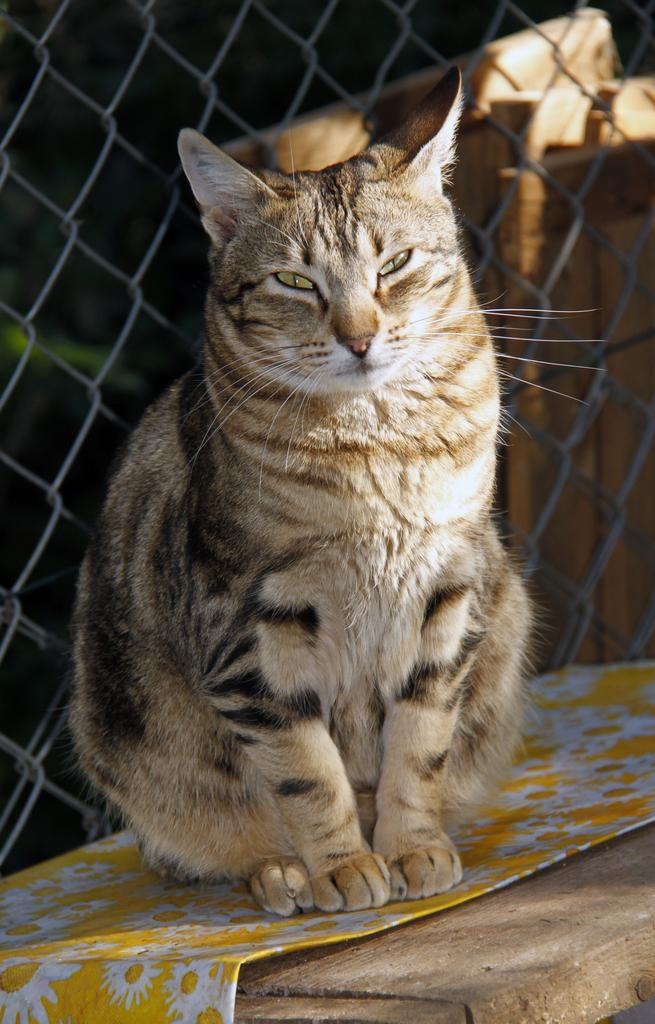What animal is on the wooden table in the image? There is a cat on a wooden table in the image. What is covering the table in the image? The table has a cover on it. What can be seen behind the cat in the image? There is a mesh fence behind the cat. What is located behind the mesh fence in the image? There are wooden planks behind the fence. What type of shock can be seen in the image? There is no shock present in the image. Is there a volleyball game happening in the image? There is no volleyball game or any reference to a volleyball in the image. 